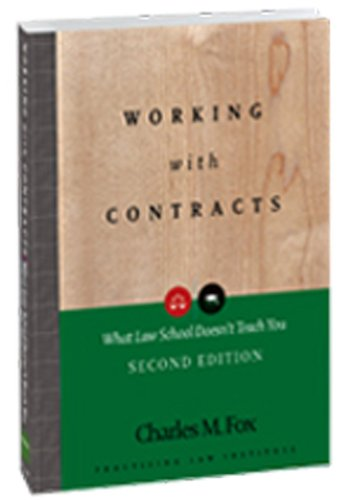Is this book related to Law? Yes, absolutely. This book is deeply entrenched in the realm of law, offering valuable insights into contract law that are crucial for legal professionals. 